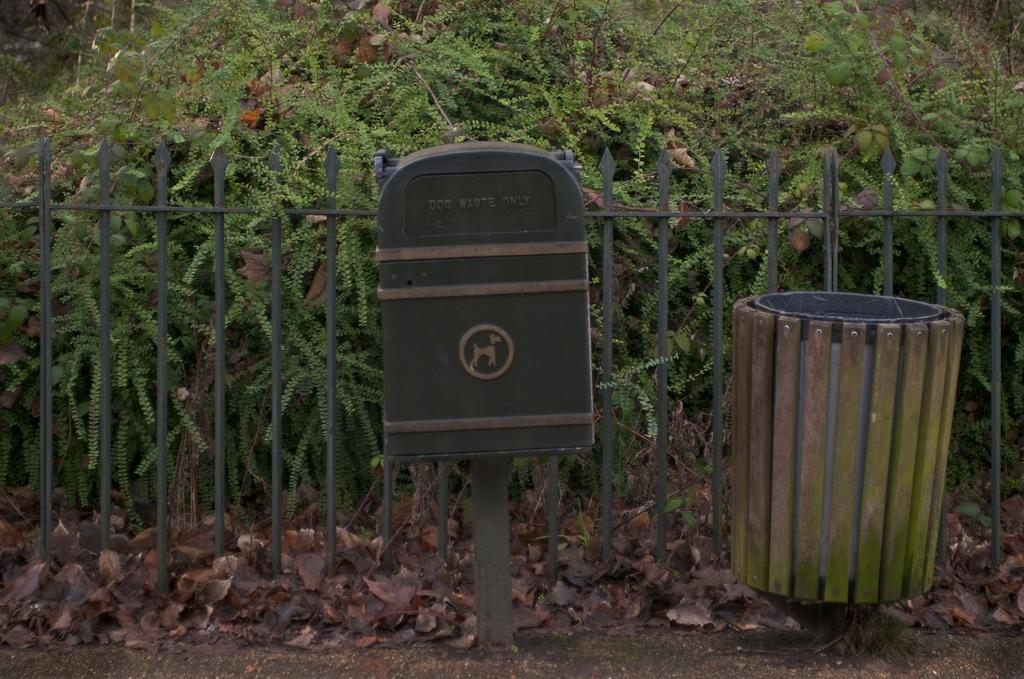<image>
Present a compact description of the photo's key features. a trash can labeled for dog waste only 